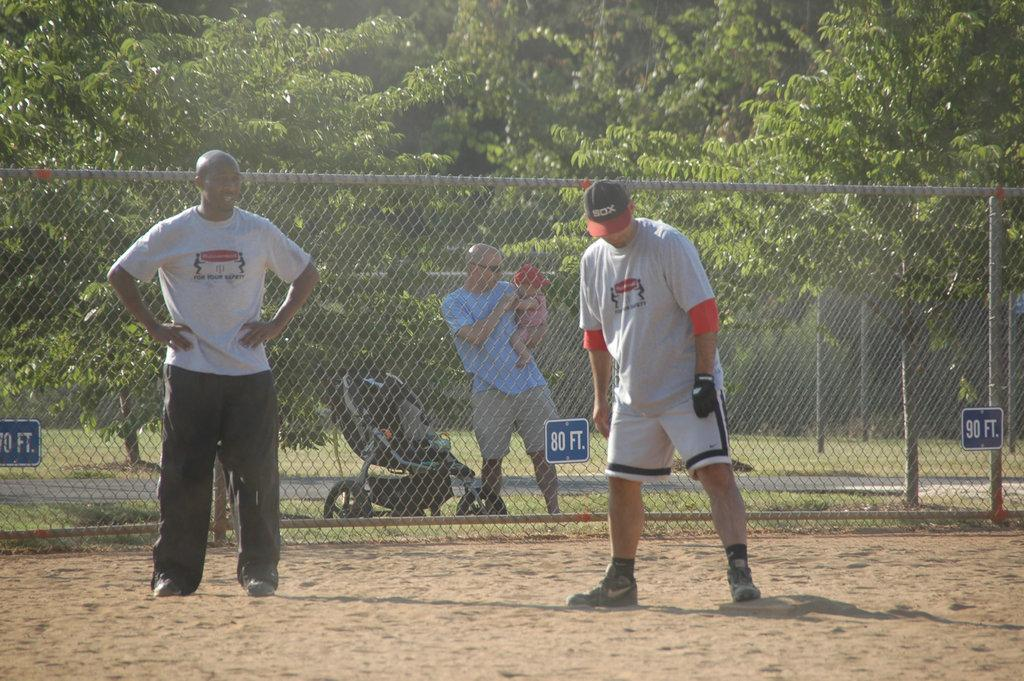<image>
Summarize the visual content of the image. In front of the man with the baby is a sign giving the distance of 80 ft. 